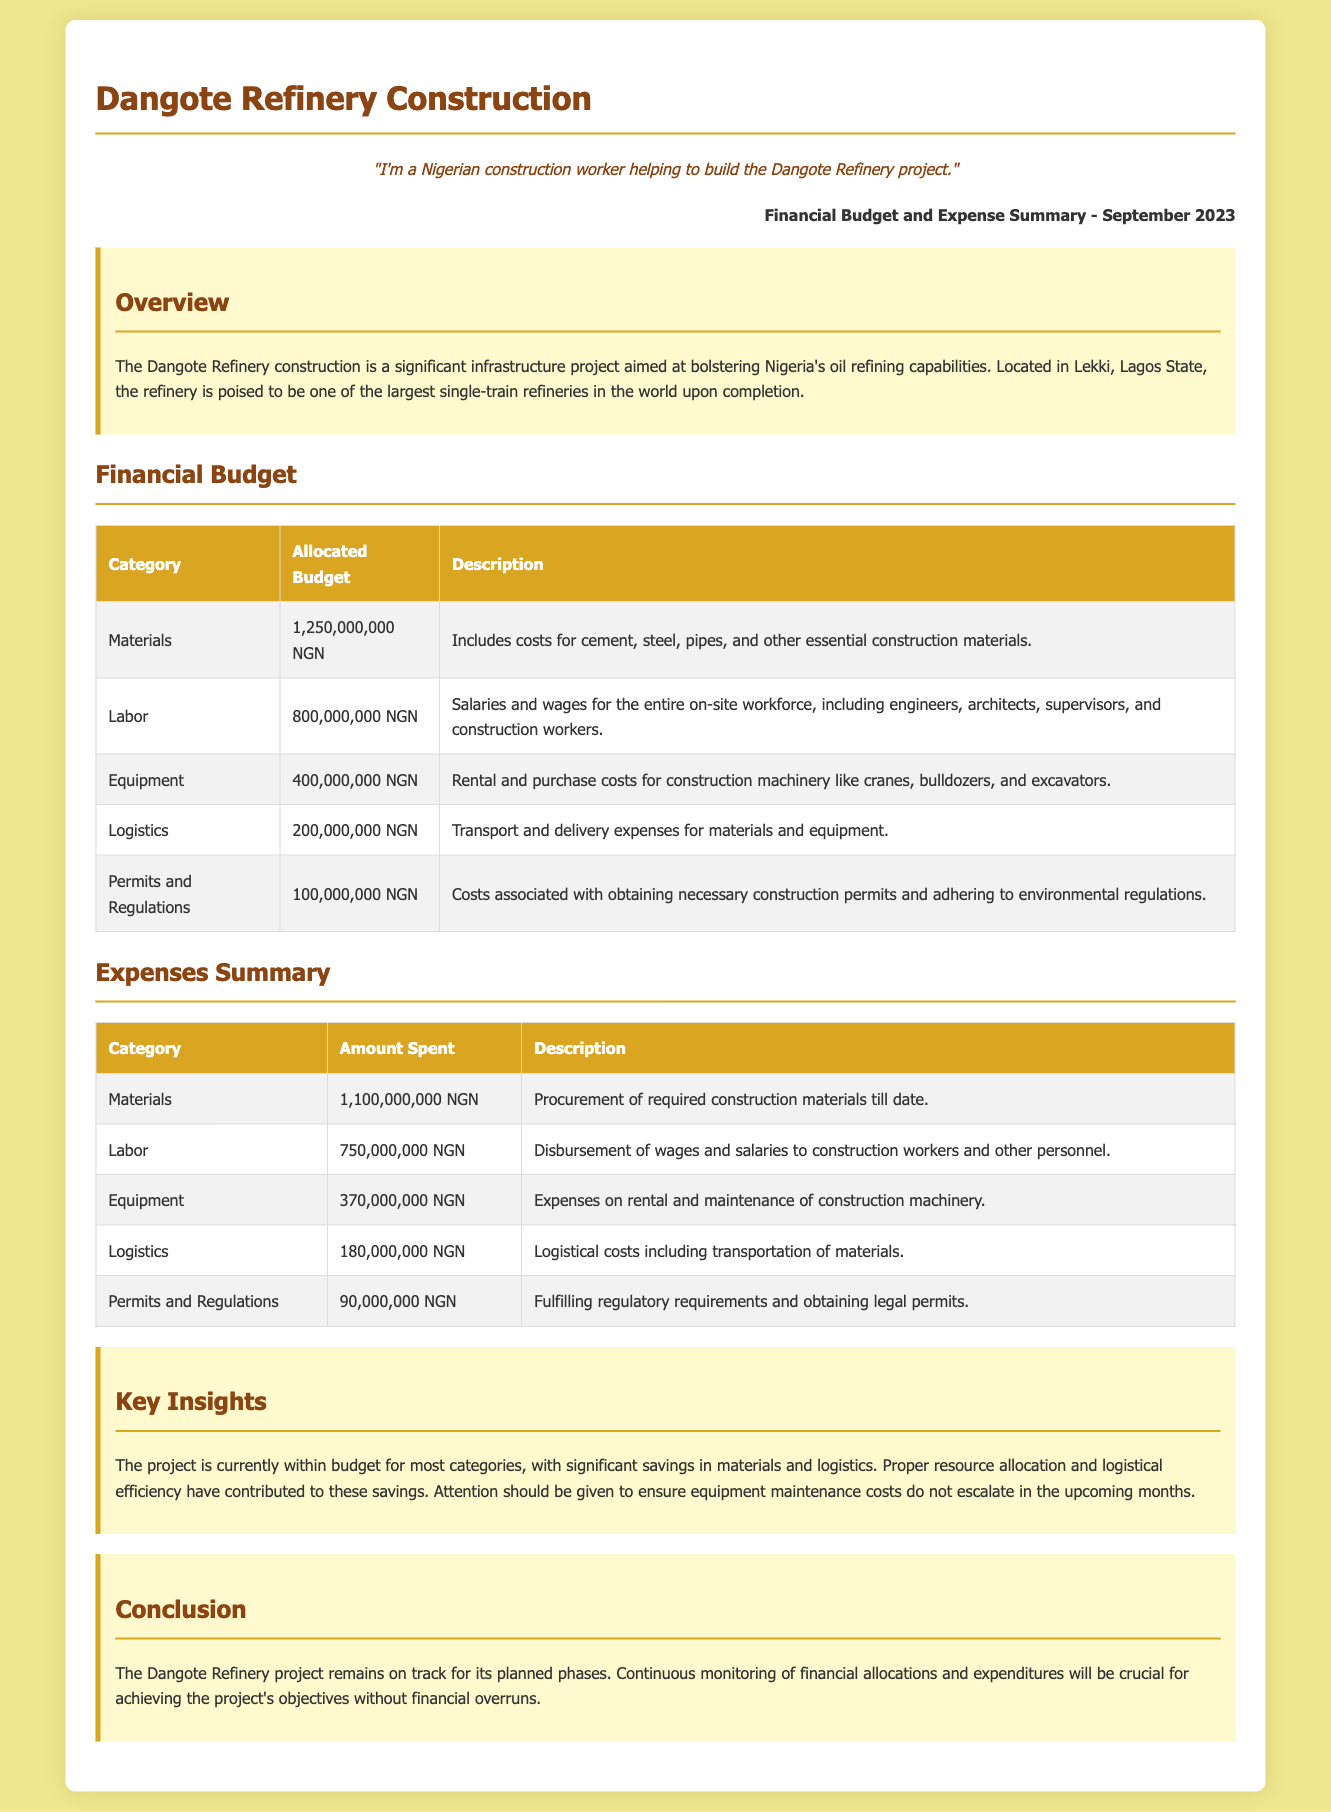What is the allocated budget for Materials? The allocated budget for Materials is listed in the Financial Budget section of the document.
Answer: 1,250,000,000 NGN What was spent on Labor? The amount spent on Labor is detailed in the Expenses Summary section of the document.
Answer: 750,000,000 NGN What is the total allocated budget for Equipment? The total allocated budget for Equipment can be found in the Financial Budget table under the Equipment category.
Answer: 400,000,000 NGN What was the spending on Logistics? The Expenses Summary section provides specific amounts spent on Logistics.
Answer: 180,000,000 NGN What category had the highest spent amount? This question requires comparing the amounts spent across multiple categories as outlined in the Expenses Summary.
Answer: Materials What is the total allocated budget across all categories? This is calculated by summing the allocated budgets for all categories to get a singular total from the Financial Budget section.
Answer: 2,850,000,000 NGN How much was spent on Permits and Regulations? The spent amount on Permits and Regulations is specifically mentioned in the Expenses Summary.
Answer: 90,000,000 NGN Which category shows the largest savings based on budget versus expenditure? This question involves reasoning about the difference between the allocated budget and the amount spent for any category in the report.
Answer: Materials What is the report date for this financial summary? The report date is prominently displayed at the top of the document and indicates when the summary was created.
Answer: September 2023 